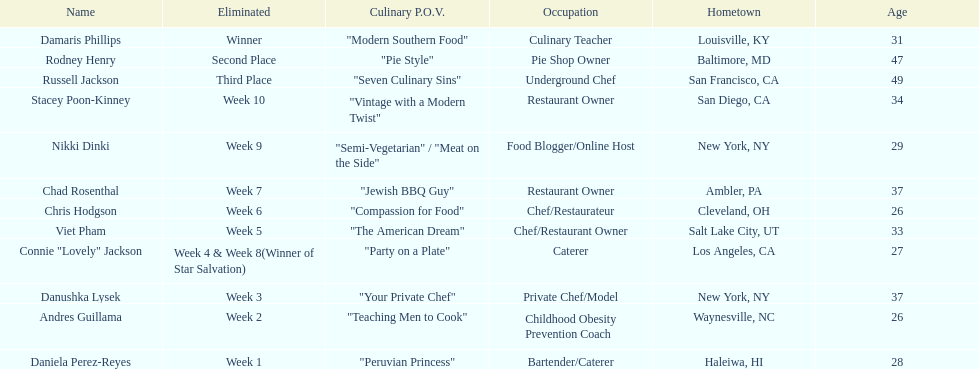Which contestant is the same age as chris hodgson? Andres Guillama. 